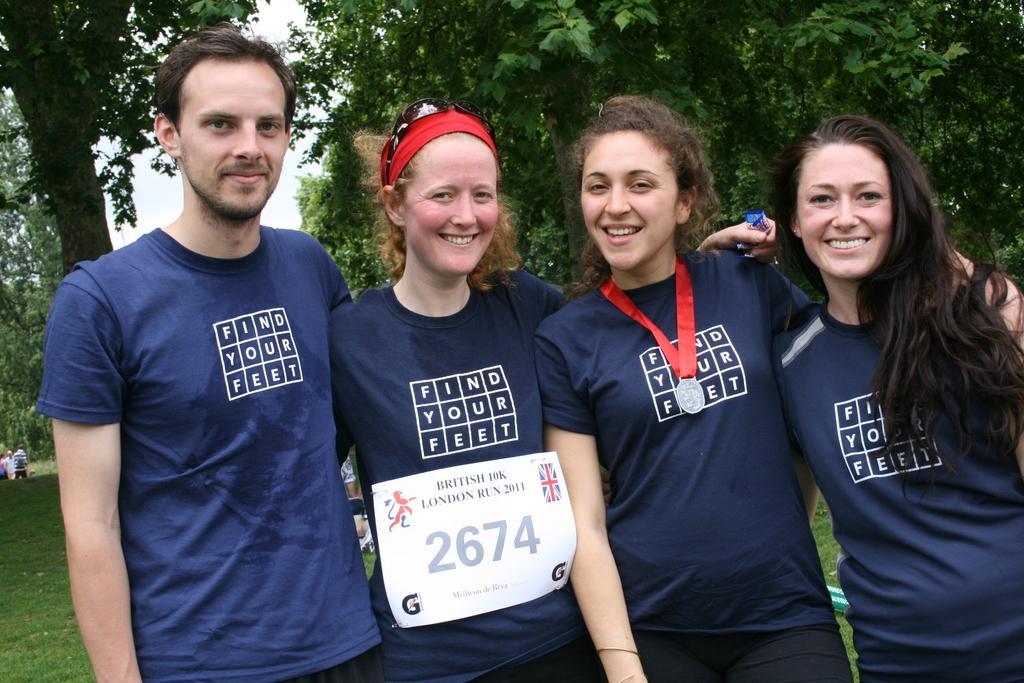In one or two sentences, can you explain what this image depicts? This image consists of four people wearing the blue T-shirts. In the middle, the woman is wearing a medal. In the background, we can see many trees. At the bottom, there is green grass. 